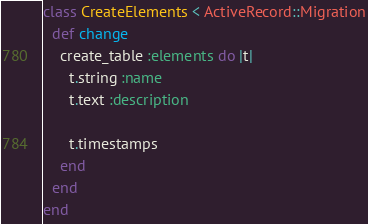Convert code to text. <code><loc_0><loc_0><loc_500><loc_500><_Ruby_>class CreateElements < ActiveRecord::Migration
  def change
    create_table :elements do |t|
      t.string :name
      t.text :description

      t.timestamps
    end
  end
end
</code> 